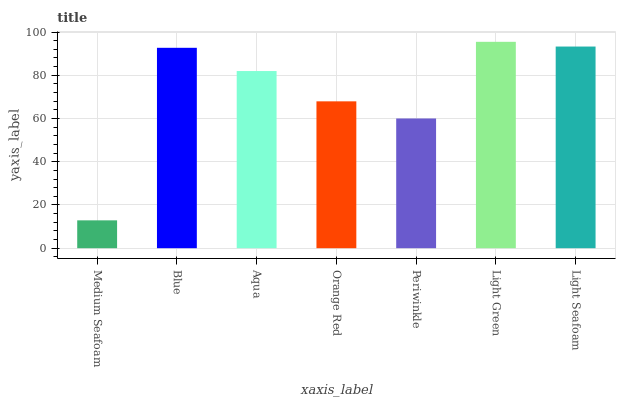Is Medium Seafoam the minimum?
Answer yes or no. Yes. Is Light Green the maximum?
Answer yes or no. Yes. Is Blue the minimum?
Answer yes or no. No. Is Blue the maximum?
Answer yes or no. No. Is Blue greater than Medium Seafoam?
Answer yes or no. Yes. Is Medium Seafoam less than Blue?
Answer yes or no. Yes. Is Medium Seafoam greater than Blue?
Answer yes or no. No. Is Blue less than Medium Seafoam?
Answer yes or no. No. Is Aqua the high median?
Answer yes or no. Yes. Is Aqua the low median?
Answer yes or no. Yes. Is Light Green the high median?
Answer yes or no. No. Is Orange Red the low median?
Answer yes or no. No. 